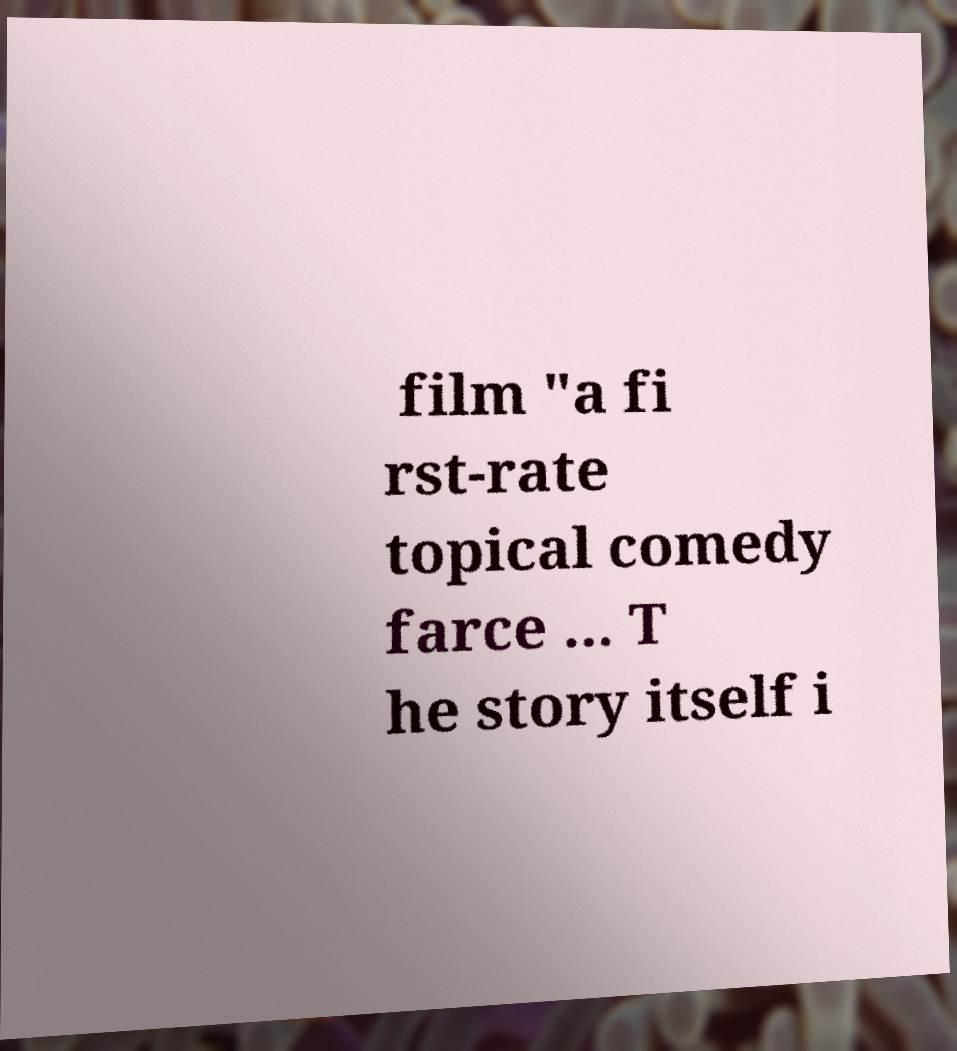Could you assist in decoding the text presented in this image and type it out clearly? film "a fi rst-rate topical comedy farce ... T he story itself i 